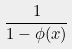Convert formula to latex. <formula><loc_0><loc_0><loc_500><loc_500>\frac { 1 } { 1 - \phi ( x ) }</formula> 